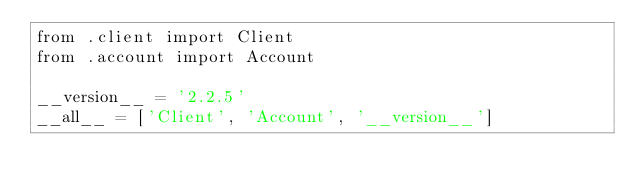Convert code to text. <code><loc_0><loc_0><loc_500><loc_500><_Python_>from .client import Client
from .account import Account

__version__ = '2.2.5'
__all__ = ['Client', 'Account', '__version__']
</code> 